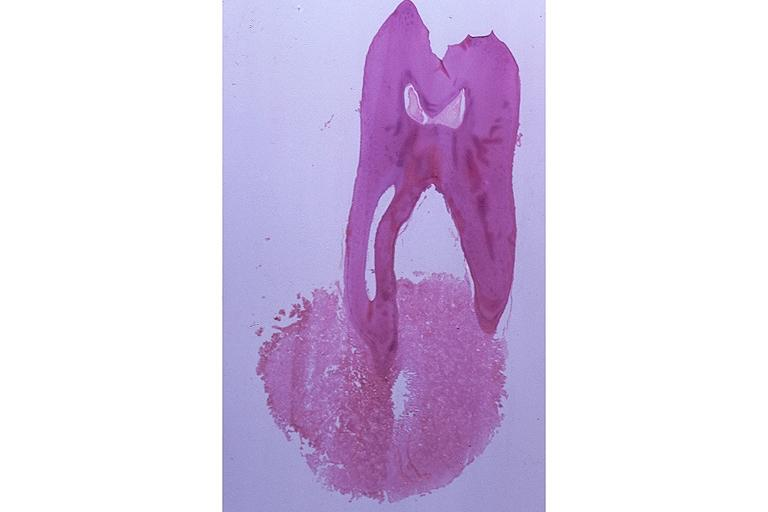does this typical thecoma with yellow foci show cementoblastoma?
Answer the question using a single word or phrase. No 